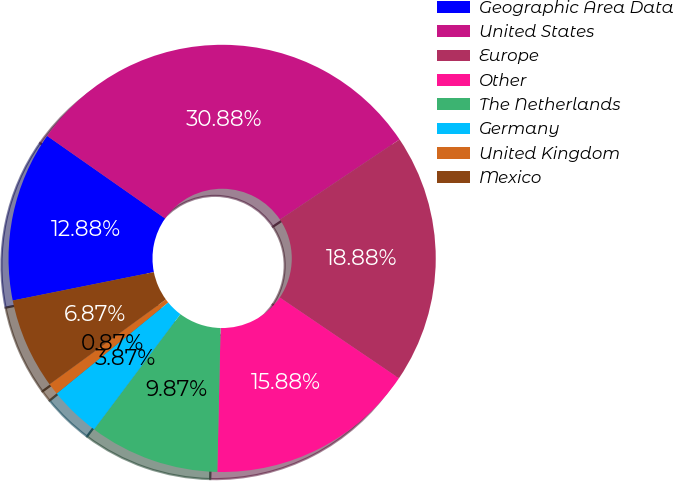Convert chart. <chart><loc_0><loc_0><loc_500><loc_500><pie_chart><fcel>Geographic Area Data<fcel>United States<fcel>Europe<fcel>Other<fcel>The Netherlands<fcel>Germany<fcel>United Kingdom<fcel>Mexico<nl><fcel>12.88%<fcel>30.88%<fcel>18.88%<fcel>15.88%<fcel>9.87%<fcel>3.87%<fcel>0.87%<fcel>6.87%<nl></chart> 